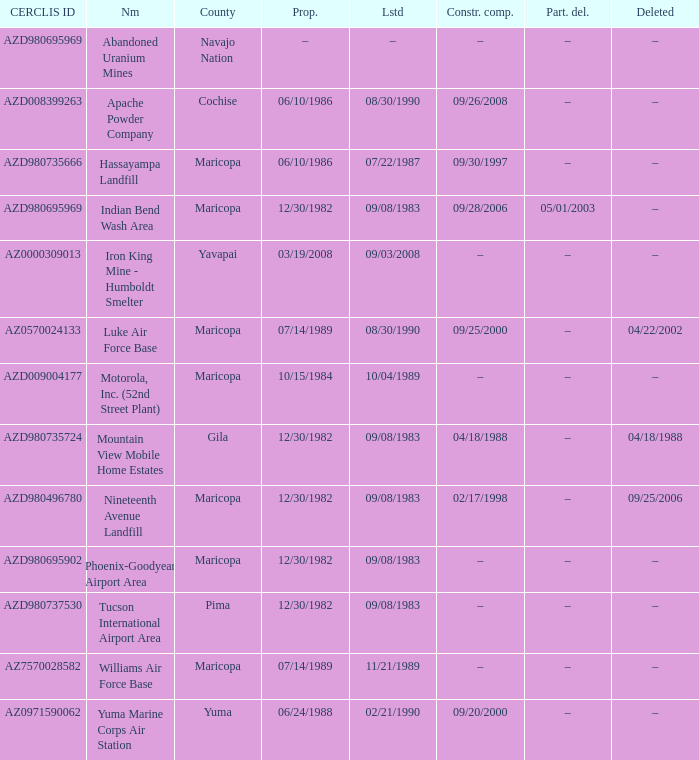What is the cerclis id when the site was proposed on 12/30/1982 and was partially deleted on 05/01/2003? AZD980695969. 